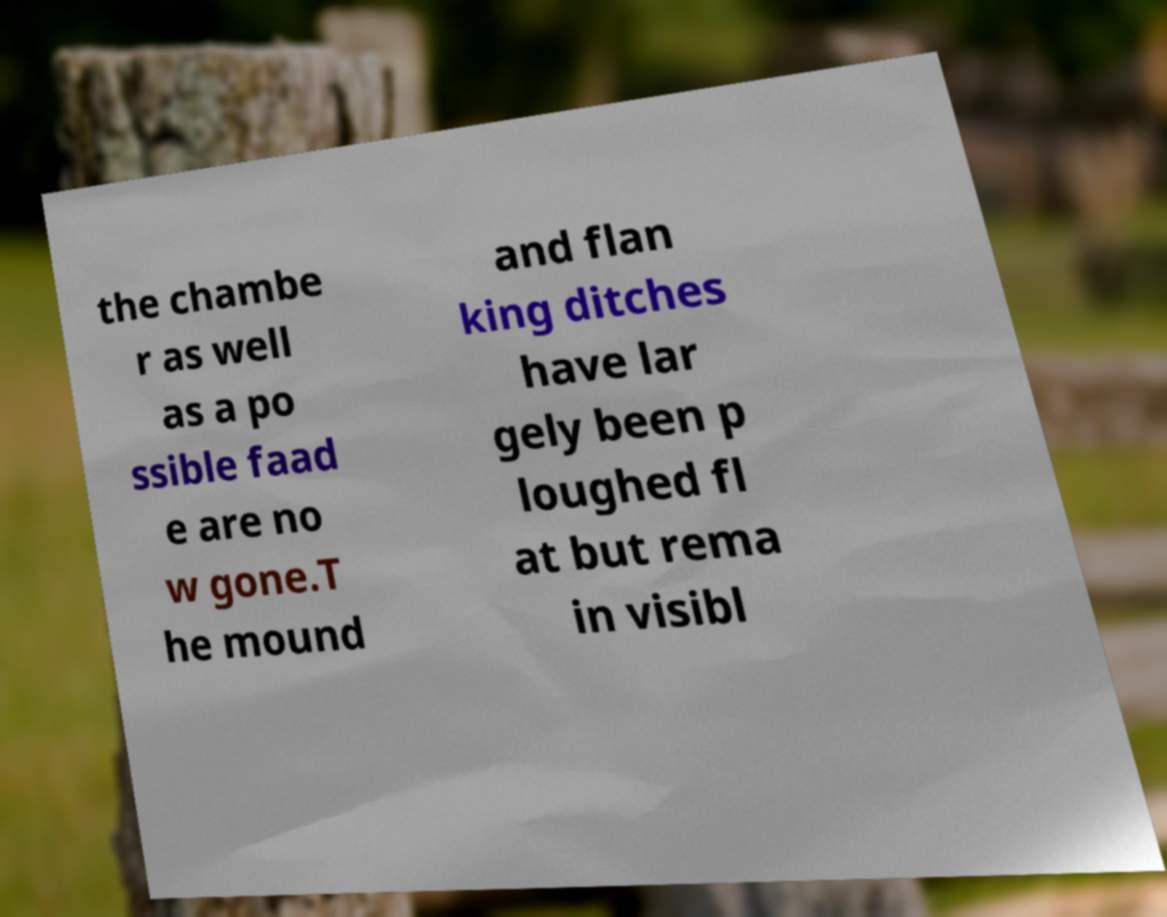Could you extract and type out the text from this image? the chambe r as well as a po ssible faad e are no w gone.T he mound and flan king ditches have lar gely been p loughed fl at but rema in visibl 